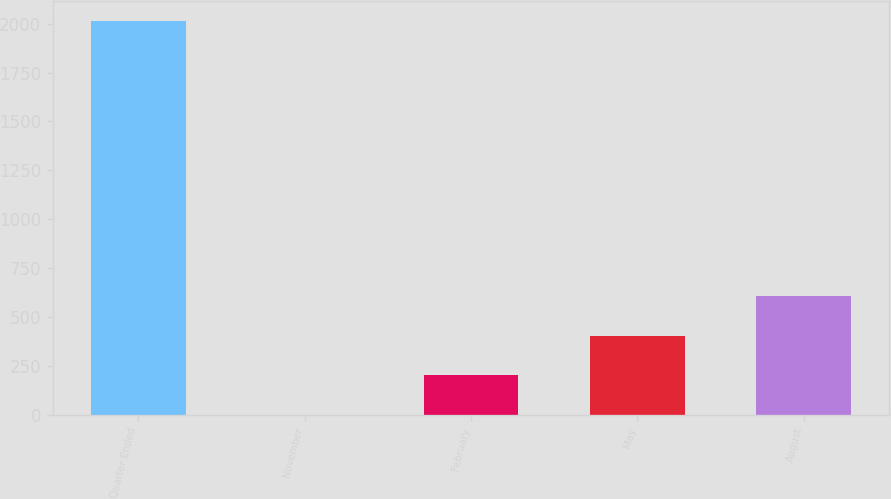<chart> <loc_0><loc_0><loc_500><loc_500><bar_chart><fcel>Quarter Ended<fcel>November<fcel>February<fcel>May<fcel>August<nl><fcel>2015<fcel>0.34<fcel>201.81<fcel>403.28<fcel>604.75<nl></chart> 